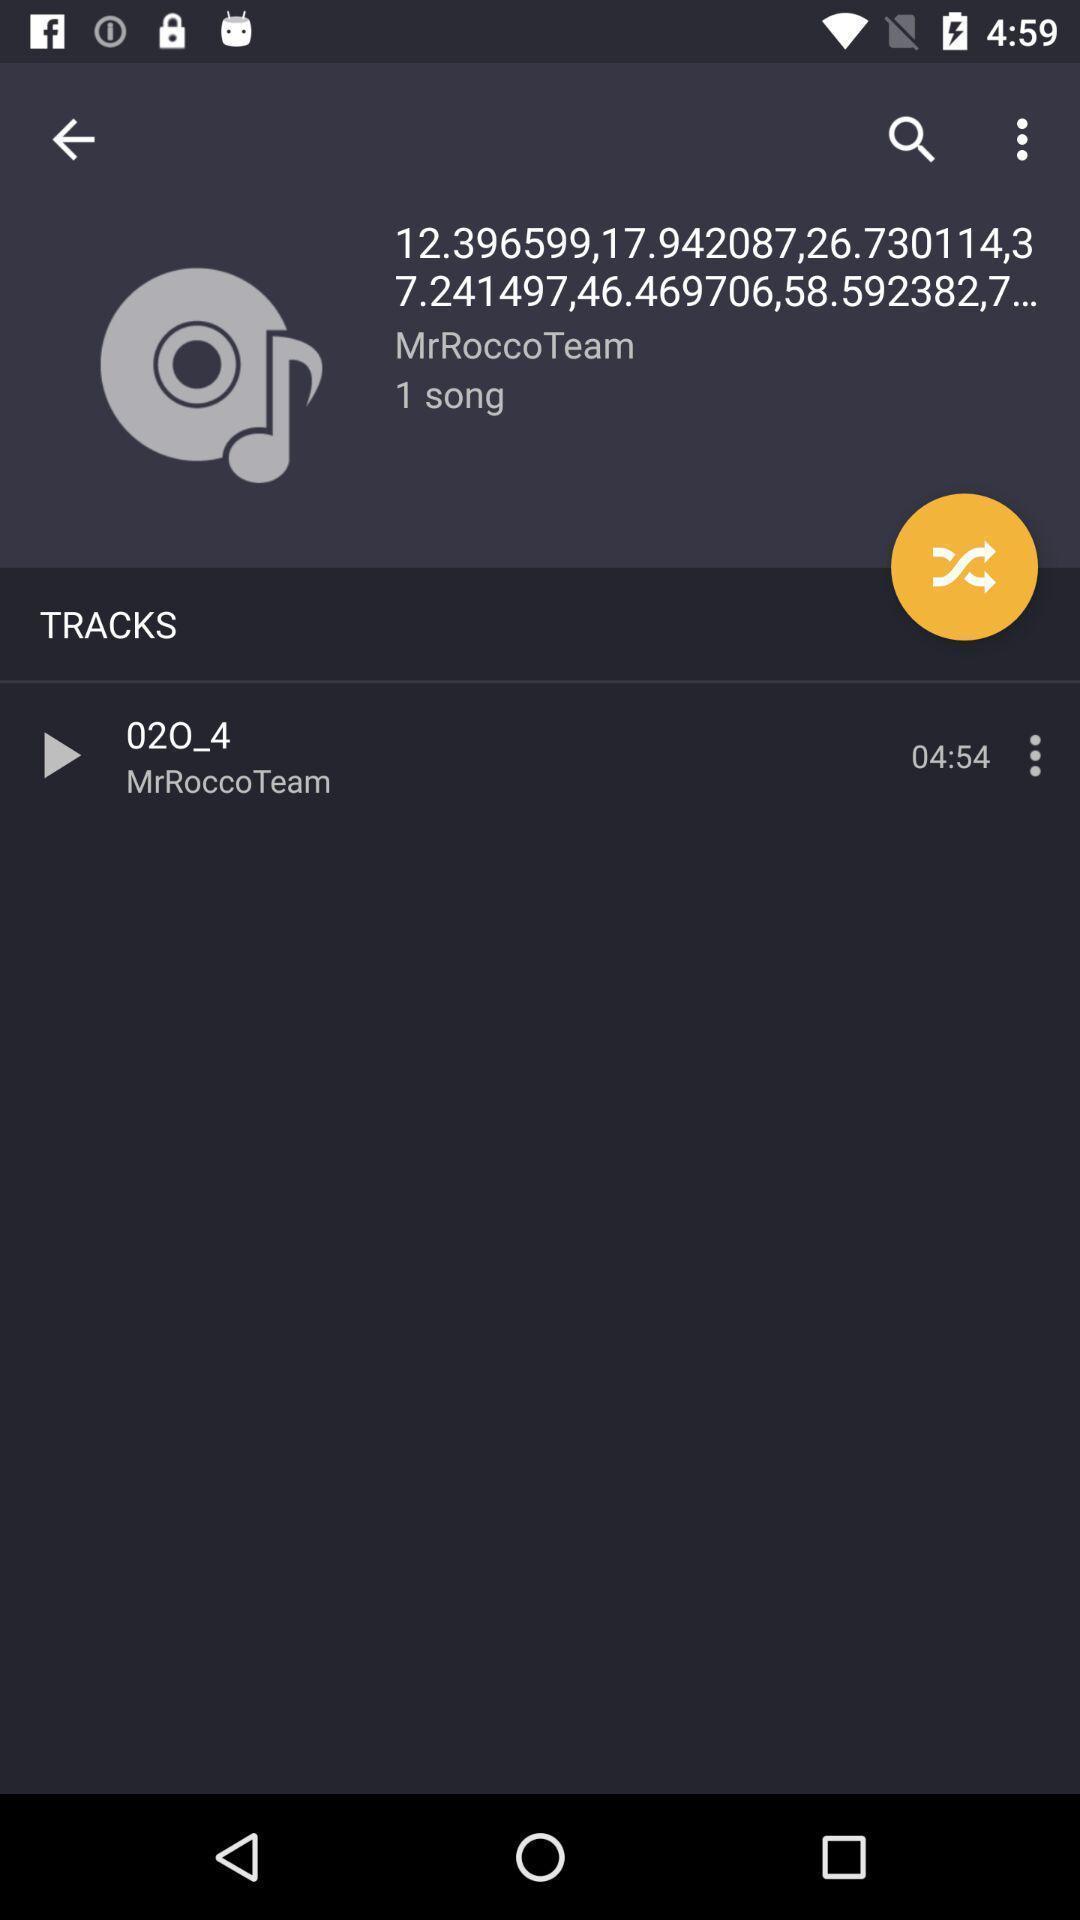What is the overall content of this screenshot? Track page displayed in a music app. 